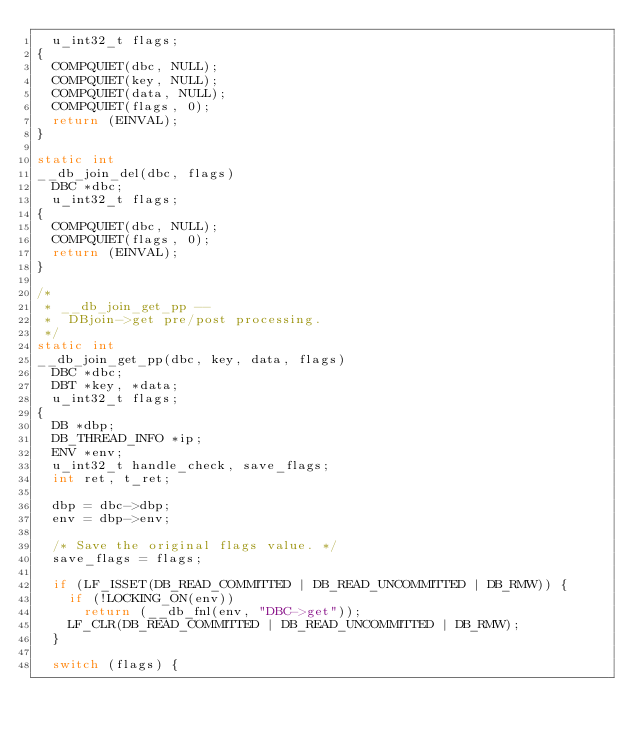Convert code to text. <code><loc_0><loc_0><loc_500><loc_500><_C_>	u_int32_t flags;
{
	COMPQUIET(dbc, NULL);
	COMPQUIET(key, NULL);
	COMPQUIET(data, NULL);
	COMPQUIET(flags, 0);
	return (EINVAL);
}

static int
__db_join_del(dbc, flags)
	DBC *dbc;
	u_int32_t flags;
{
	COMPQUIET(dbc, NULL);
	COMPQUIET(flags, 0);
	return (EINVAL);
}

/*
 * __db_join_get_pp --
 *	DBjoin->get pre/post processing.
 */
static int
__db_join_get_pp(dbc, key, data, flags)
	DBC *dbc;
	DBT *key, *data;
	u_int32_t flags;
{
	DB *dbp;
	DB_THREAD_INFO *ip;
	ENV *env;
	u_int32_t handle_check, save_flags;
	int ret, t_ret;

	dbp = dbc->dbp;
	env = dbp->env;

	/* Save the original flags value. */
	save_flags = flags;

	if (LF_ISSET(DB_READ_COMMITTED | DB_READ_UNCOMMITTED | DB_RMW)) {
		if (!LOCKING_ON(env))
			return (__db_fnl(env, "DBC->get"));
		LF_CLR(DB_READ_COMMITTED | DB_READ_UNCOMMITTED | DB_RMW);
	}

	switch (flags) {</code> 